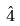<formula> <loc_0><loc_0><loc_500><loc_500>\hat { 4 }</formula> 